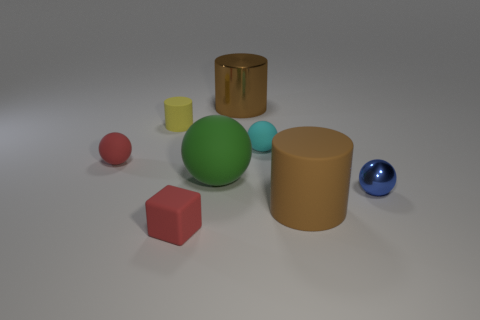Subtract all red cubes. How many brown cylinders are left? 2 Subtract all rubber cylinders. How many cylinders are left? 1 Subtract all cyan spheres. How many spheres are left? 3 Add 1 yellow objects. How many objects exist? 9 Subtract all cylinders. How many objects are left? 5 Subtract 1 red cubes. How many objects are left? 7 Subtract all cyan spheres. Subtract all blue cubes. How many spheres are left? 3 Subtract all small purple spheres. Subtract all tiny yellow objects. How many objects are left? 7 Add 4 small red cubes. How many small red cubes are left? 5 Add 4 tiny red matte cubes. How many tiny red matte cubes exist? 5 